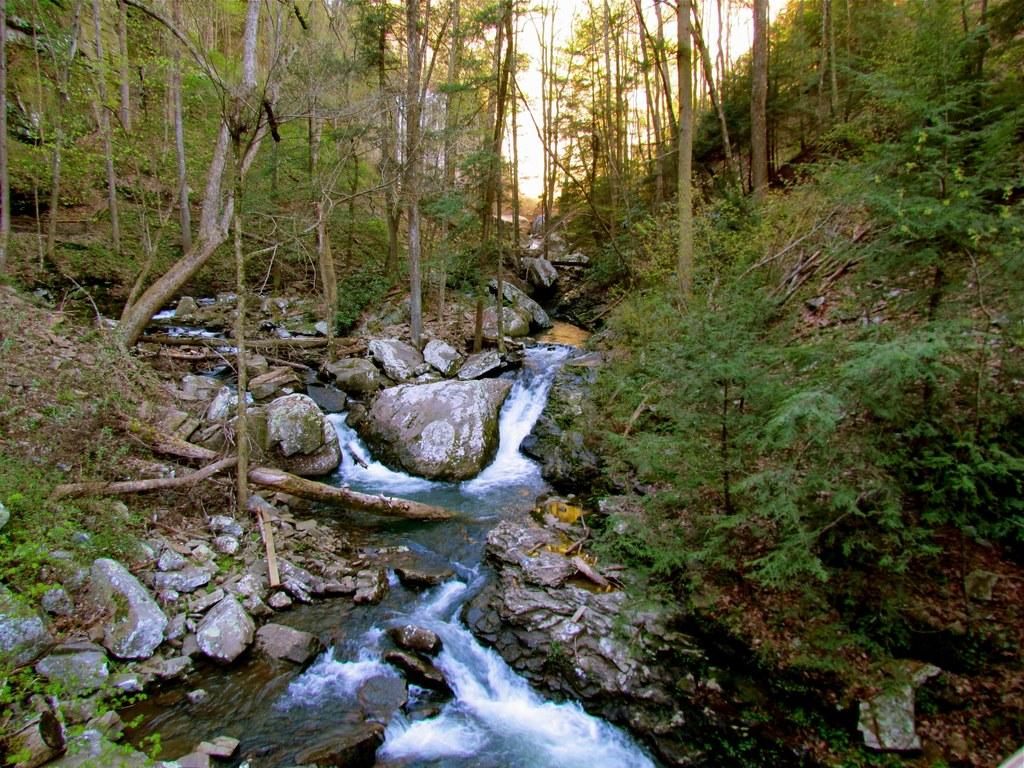What is happening in the image? There is water flow in the image. What can be seen in the water flow? There are rocks in the image. What other natural elements are present in the image? There are plants and trees in the image. What is visible in the background of the image? The sky is visible in the background of the image. How many socks are hanging on the trees in the image? There are no socks present in the image; it features water flow, rocks, plants, trees, and a visible sky. 